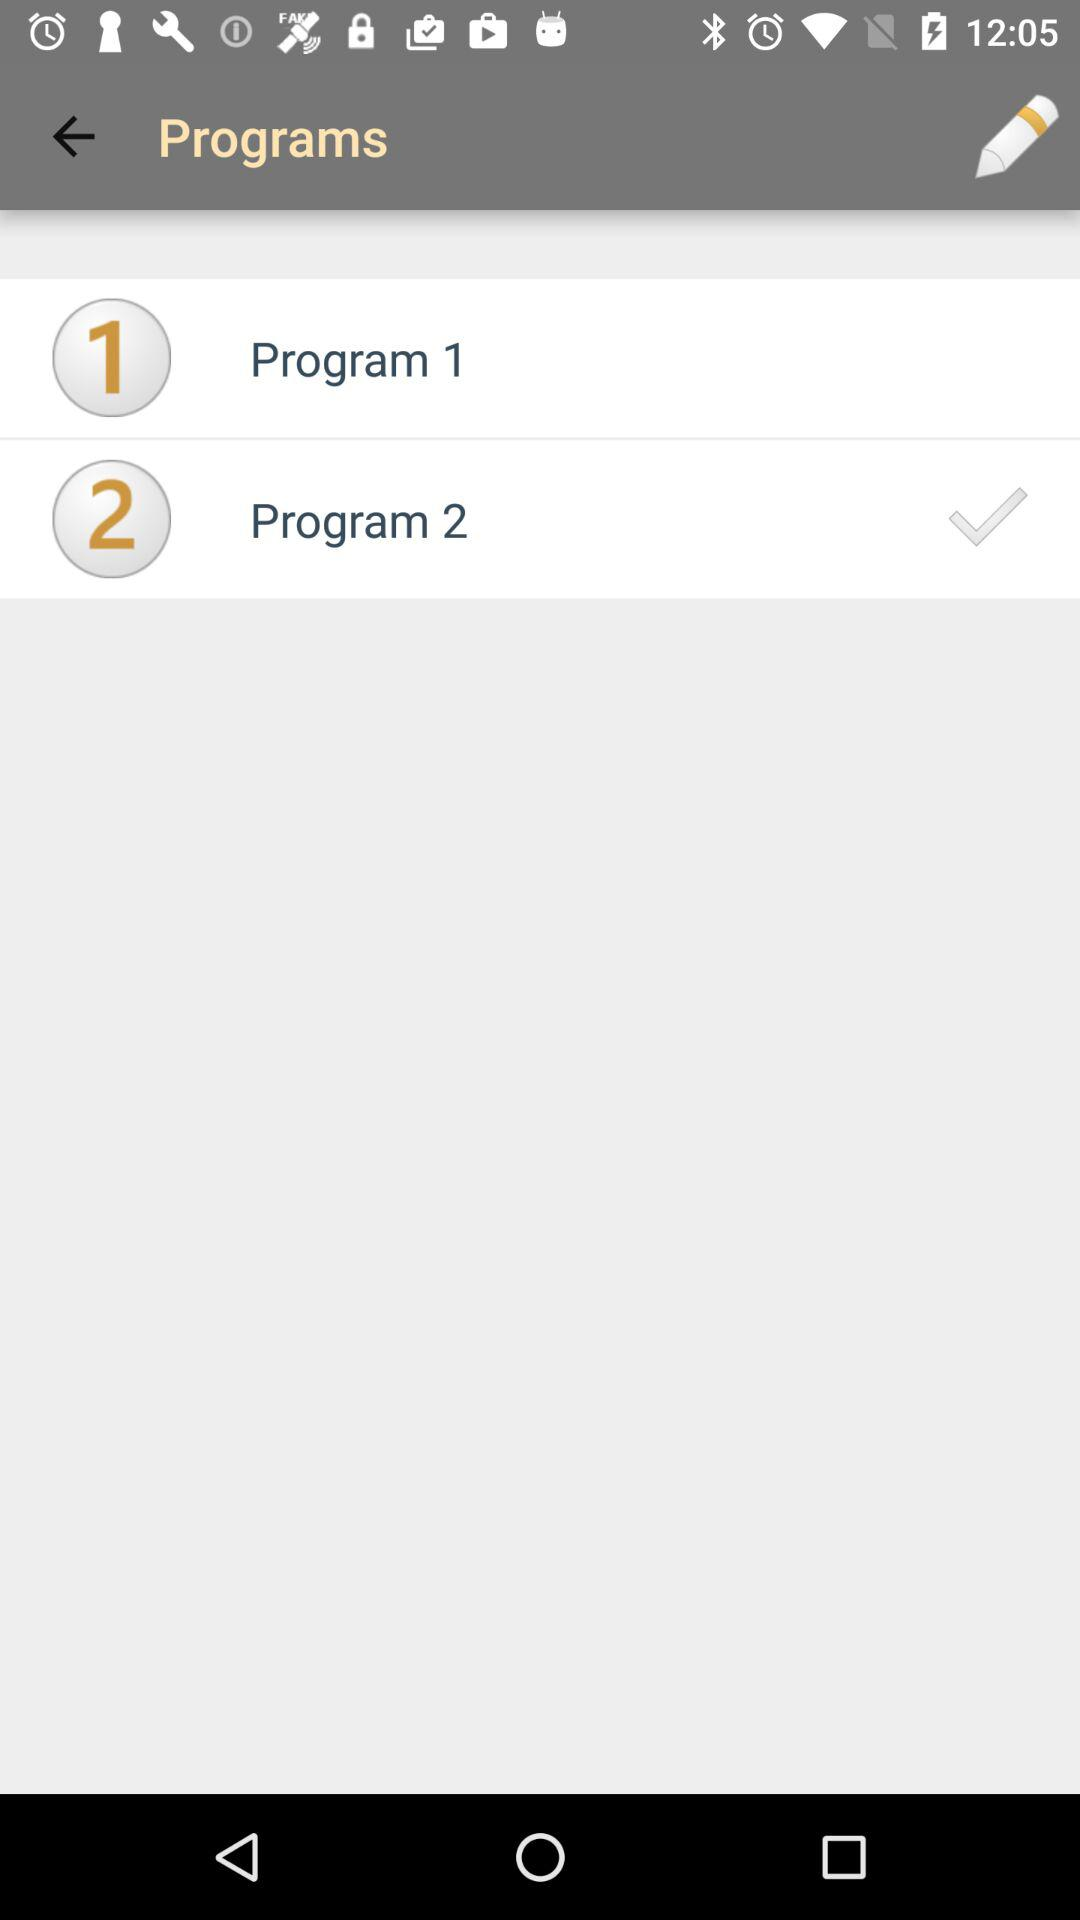How many programs are checked?
Answer the question using a single word or phrase. 1 